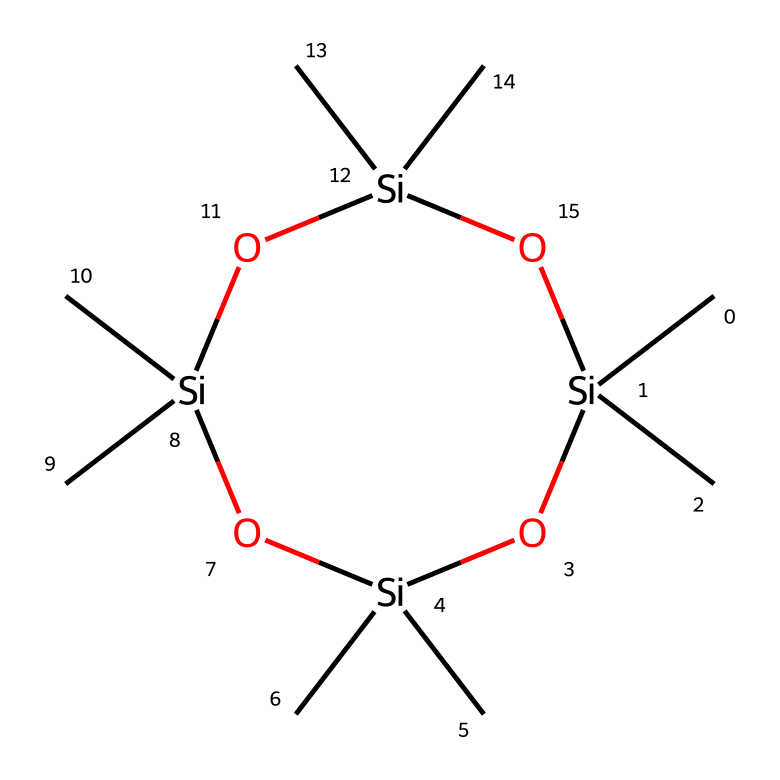What is the name of this chemical? The chemical structure corresponds to octamethylcyclotetrasiloxane, which is indicated by its siloxane backbone due to the alternating silicon and oxygen atoms as confirmed by the SMILES representation.
Answer: octamethylcyclotetrasiloxane How many silicon atoms are present in this structure? By examining the structure, there are four silicon atoms represented, shown explicitly in the cyclic arrangement of the chemical.
Answer: four How many oxygen atoms are present in this molecule? The structure includes four oxygen atoms, which are identifiable as they link the silicon atoms in the siloxane ring.
Answer: four What type of bonding exists between silicon and oxygen in this chemical? The bonding type between silicon and oxygen is primarily covalent in nature due to the sharing of electrons between these nonmetals, typical of siloxanes.
Answer: covalent What is the general class of this chemical? This chemical falls within the class of siloxanes, which are characterized by their silicate backbone, that includes alternating silicon and oxygen atoms, leading to a unique chemical behavior.
Answer: siloxanes What does the methyl group indicate about the properties of this chemical? The presence of methyl groups suggests that the chemical is likely to be less polar and more hydrophobic, thus influencing its solubility and interaction with other substances typically found in personal care products.
Answer: hydrophobic 